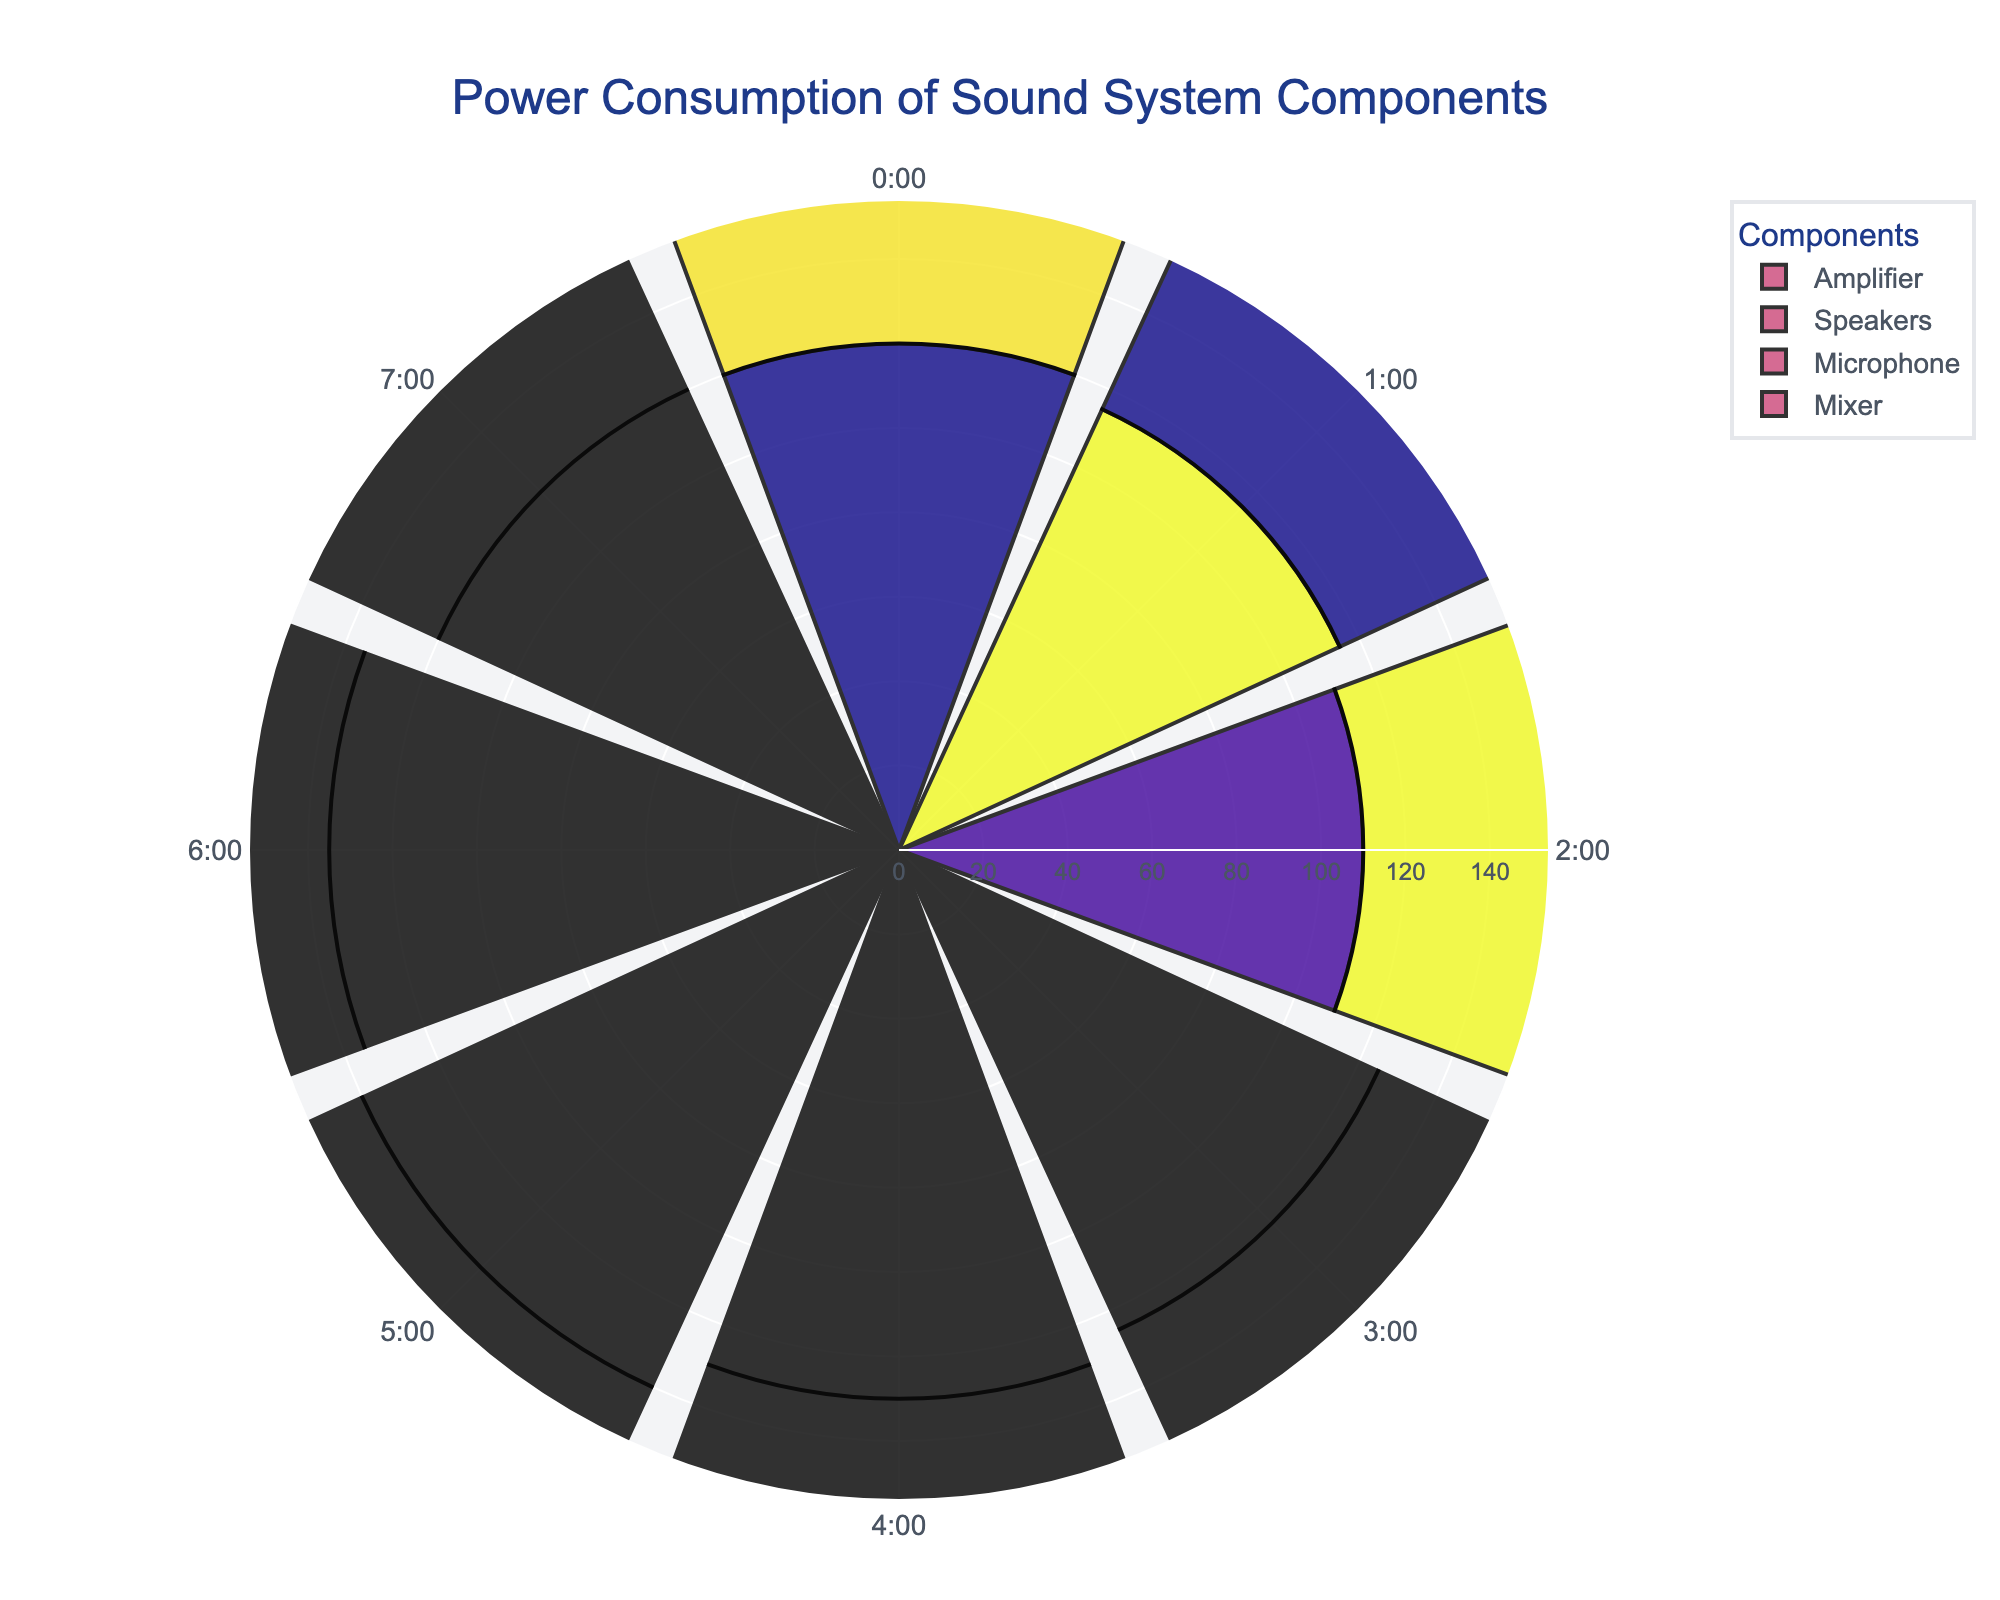What's the title of the chart? The title is typically at the top of the chart. From the provided data, it's "Power Consumption of Sound System Components".
Answer: Power Consumption of Sound System Components Which component has the highest power consumption? From the chart, the slice extending the furthest radially shows the component with the highest power consumption. The Amplifier has the highest power consumption.
Answer: Amplifier At what time does the Mixer component consume the most power? Look for the longest radial extension for Mixer, which is at 5:00.
Answer: 5:00 Which component has the most uniform power consumption over time? Compare the radial lengths of the slices for each component. The Microphone's power consumption is most uniform.
Answer: Microphone How does the power consumption of the Speakers at 4:00 compare to the Mixer's at the same time? Check both radial lengths at 4:00. The Speakers have a power consumption of 53W, and the Mixer has 34W, so the Speakers consume more.
Answer: The Speakers consume more power What's the total power consumption of the Mixer at 3:00 and 5:00 combined? From the Mixer data, at 3:00 the power consumption is 33W and at 5:00 it is 36W. Summing these gives 33 + 36 = 69W.
Answer: 69W Which time shows the lowest power consumption for the Amplifier? Look at each slice for the Amplifier and find the shortest. This is at 2:00 with a power consumption of 110W.
Answer: 2:00 How much higher is the power consumption of the Amplifier at 6:00 compared to the Mixer at the same time? The Amplifier's consumption at 6:00 is 135W, and the Mixer's is 35W. The difference is 135 - 35 = 100W.
Answer: 100W What is the average power consumption of the Microphone component? Add all the power consumption values for the Microphone: 10 + 12 + 11 + 13 + 12 + 14 + 13 + 10 = 95. Divide by the number of data points, 8. The average is 95 / 8 = 11.875W.
Answer: 11.875W Which component shows the largest increase in power consumption from 0:00 to 5:00? Calculate the difference from 0:00 to 5:00 for each component: 
  Amplifier: 140 - 120 = 20W,
  Speakers: 55 - 50 = 5W,
  Microphone: 14 - 10 = 4W,
  Mixer: 36 - 30 = 6W.
  The Amplifier shows the largest increase.
Answer: Amplifier 